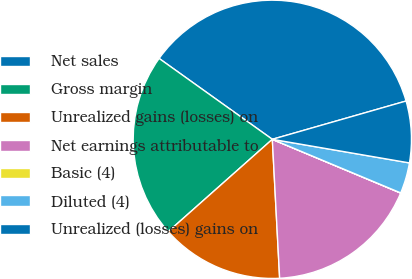Convert chart to OTSL. <chart><loc_0><loc_0><loc_500><loc_500><pie_chart><fcel>Net sales<fcel>Gross margin<fcel>Unrealized gains (losses) on<fcel>Net earnings attributable to<fcel>Basic (4)<fcel>Diluted (4)<fcel>Unrealized (losses) gains on<nl><fcel>35.69%<fcel>21.42%<fcel>14.29%<fcel>17.85%<fcel>0.02%<fcel>3.58%<fcel>7.15%<nl></chart> 